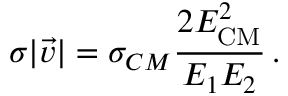<formula> <loc_0><loc_0><loc_500><loc_500>\sigma | \vec { v } | = \sigma _ { C M } \frac { 2 E _ { C M } ^ { 2 } } { E _ { 1 } E _ { 2 } } \, .</formula> 